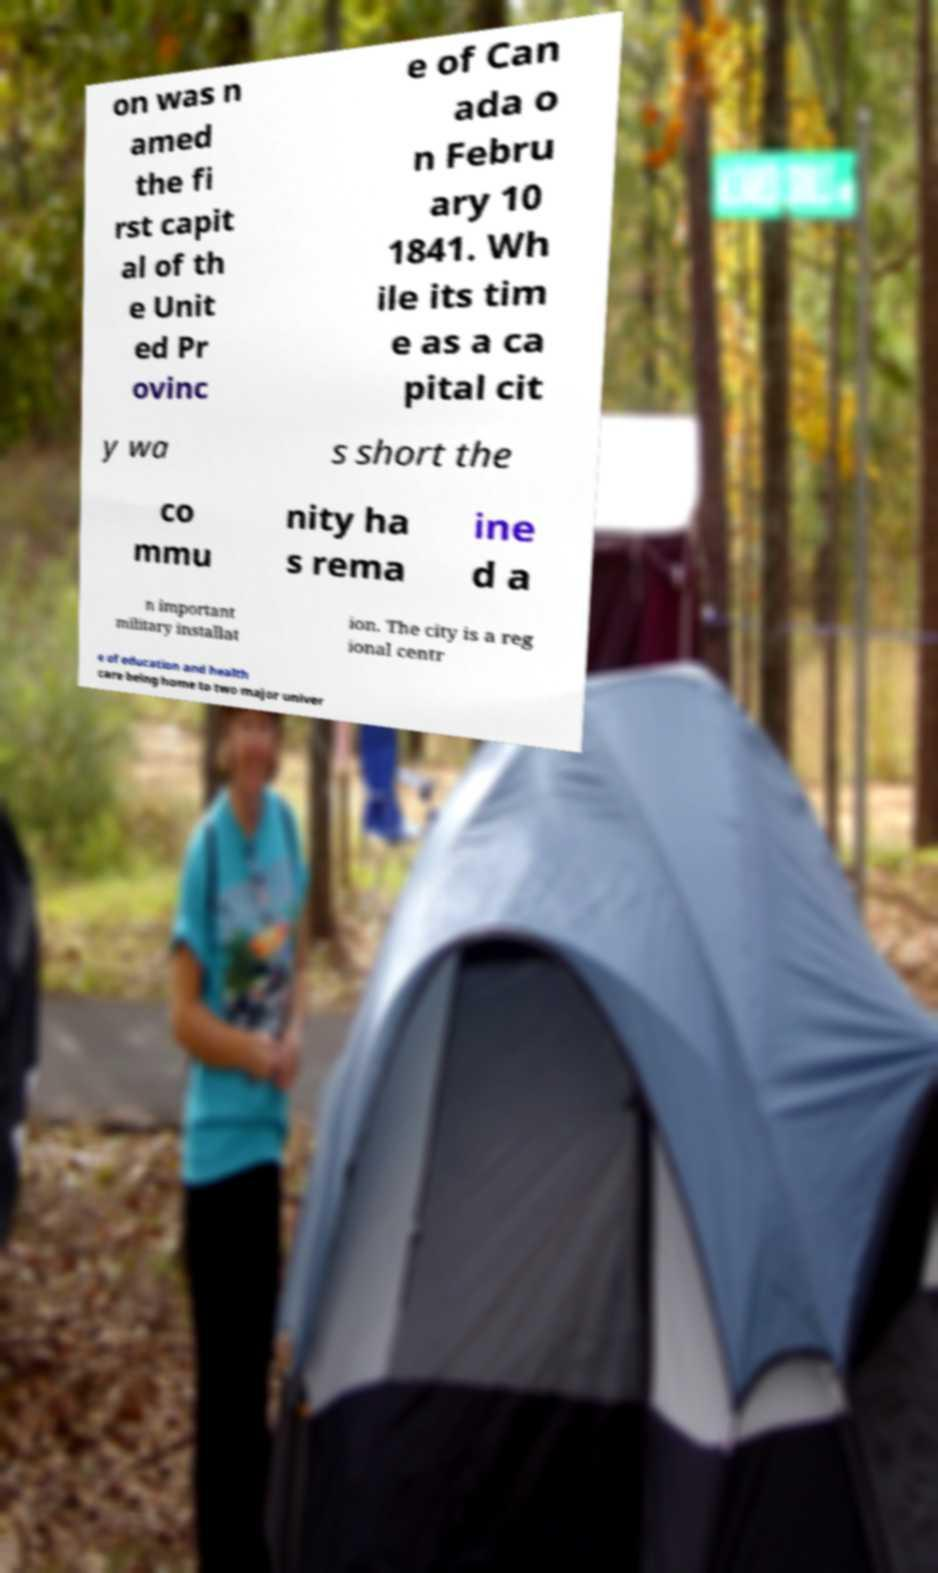Can you accurately transcribe the text from the provided image for me? on was n amed the fi rst capit al of th e Unit ed Pr ovinc e of Can ada o n Febru ary 10 1841. Wh ile its tim e as a ca pital cit y wa s short the co mmu nity ha s rema ine d a n important military installat ion. The city is a reg ional centr e of education and health care being home to two major univer 